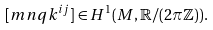Convert formula to latex. <formula><loc_0><loc_0><loc_500><loc_500>[ m n q k ^ { i j } ] \in H ^ { 1 } ( M , \mathbb { R } / ( 2 \pi \mathbb { Z } ) ) .</formula> 